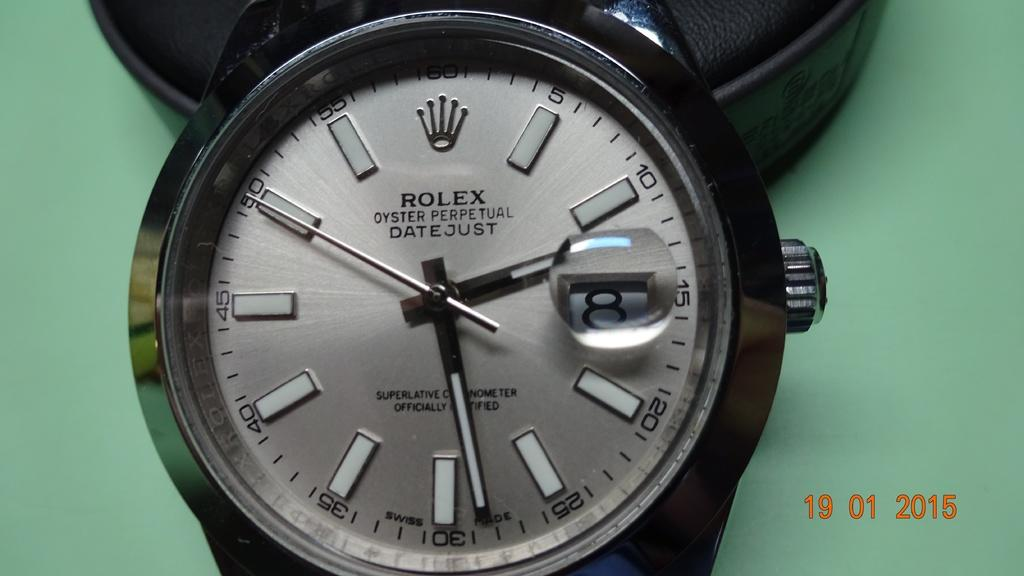<image>
Share a concise interpretation of the image provided. A black Rolex watch has the word oyster on it. 